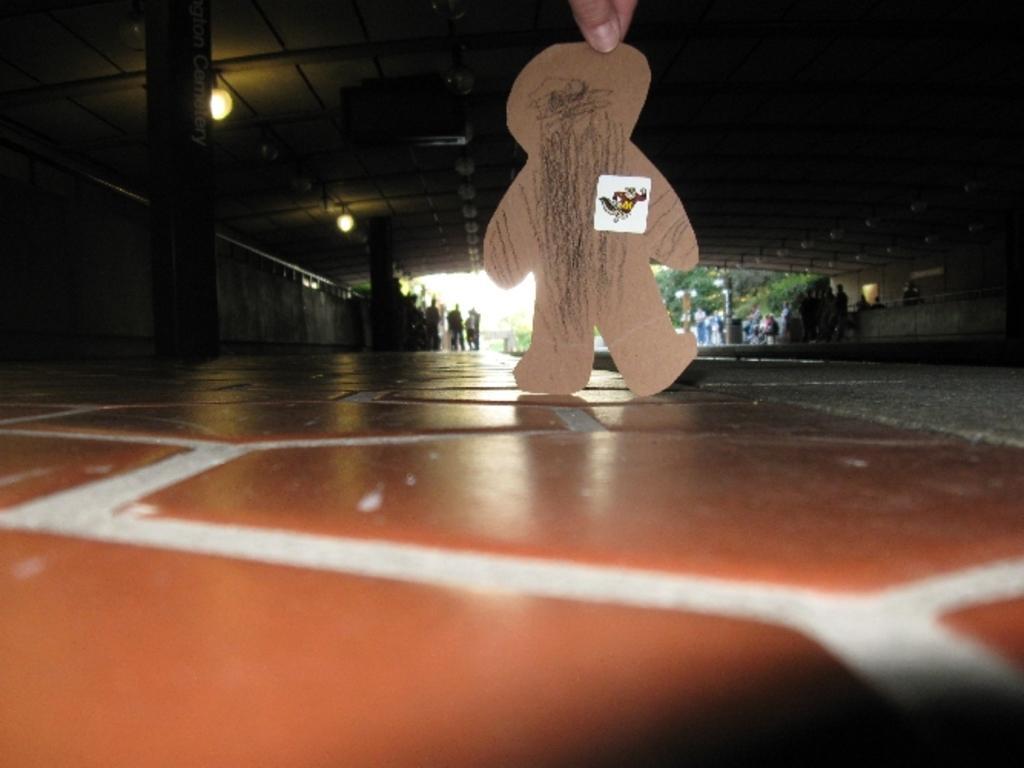Describe this image in one or two sentences. In this image there is a person holding a cardboard piece which is in the shape of a person, and in the background there are lights, group of people and trees. 